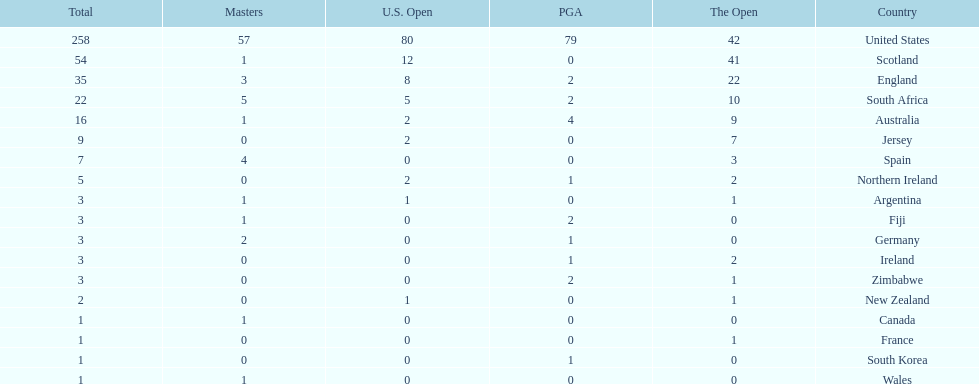Parse the full table. {'header': ['Total', 'Masters', 'U.S. Open', 'PGA', 'The Open', 'Country'], 'rows': [['258', '57', '80', '79', '42', 'United States'], ['54', '1', '12', '0', '41', 'Scotland'], ['35', '3', '8', '2', '22', 'England'], ['22', '5', '5', '2', '10', 'South Africa'], ['16', '1', '2', '4', '9', 'Australia'], ['9', '0', '2', '0', '7', 'Jersey'], ['7', '4', '0', '0', '3', 'Spain'], ['5', '0', '2', '1', '2', 'Northern Ireland'], ['3', '1', '1', '0', '1', 'Argentina'], ['3', '1', '0', '2', '0', 'Fiji'], ['3', '2', '0', '1', '0', 'Germany'], ['3', '0', '0', '1', '2', 'Ireland'], ['3', '0', '0', '2', '1', 'Zimbabwe'], ['2', '0', '1', '0', '1', 'New Zealand'], ['1', '1', '0', '0', '0', 'Canada'], ['1', '0', '0', '0', '1', 'France'], ['1', '0', '0', '1', '0', 'South Korea'], ['1', '1', '0', '0', '0', 'Wales']]} How many total championships does spain have? 7. 